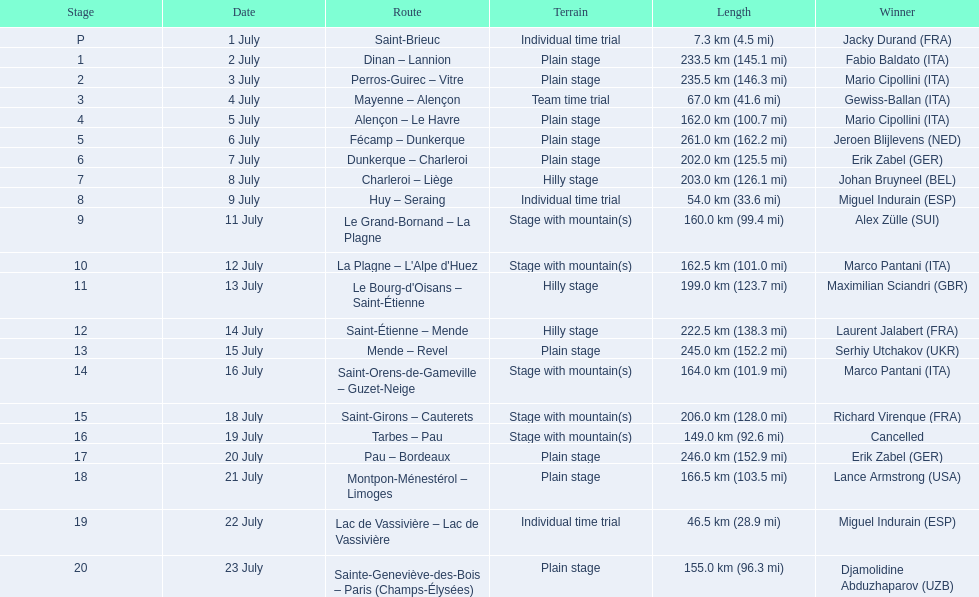Which itineraries were at least 100 kilometers? Dinan - Lannion, Perros-Guirec - Vitre, Alençon - Le Havre, Fécamp - Dunkerque, Dunkerque - Charleroi, Charleroi - Liège, Le Grand-Bornand - La Plagne, La Plagne - L'Alpe d'Huez, Le Bourg-d'Oisans - Saint-Étienne, Saint-Étienne - Mende, Mende - Revel, Saint-Orens-de-Gameville - Guzet-Neige, Saint-Girons - Cauterets, Tarbes - Pau, Pau - Bordeaux, Montpon-Ménestérol - Limoges, Sainte-Geneviève-des-Bois - Paris (Champs-Élysées). 